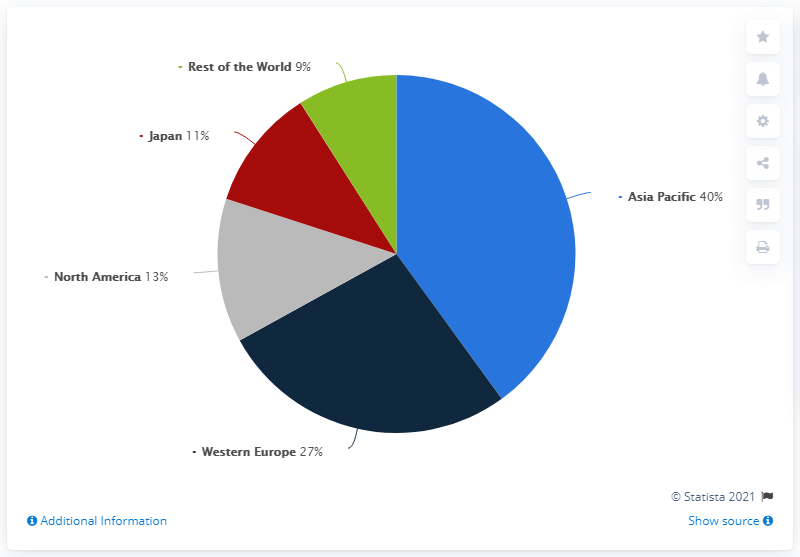Point out several critical features in this image. In 2020, the North American region accounted for approximately 13% of Bottega Veneta's global revenue. If we add Japan and North America and subtract them from Asia Pacific, the resulting percentage would be 16%. The value of the green color in the pie chart is 9%. 